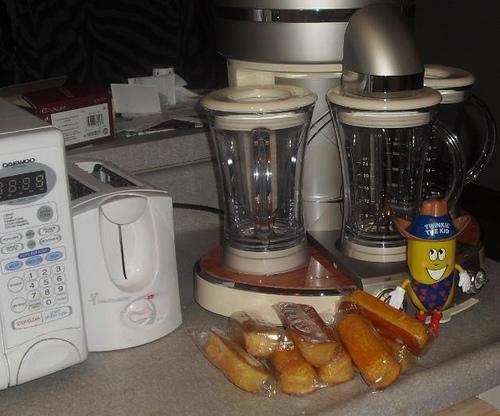How many blenders?
Give a very brief answer. 3. How many toasters are in the photo?
Give a very brief answer. 1. 